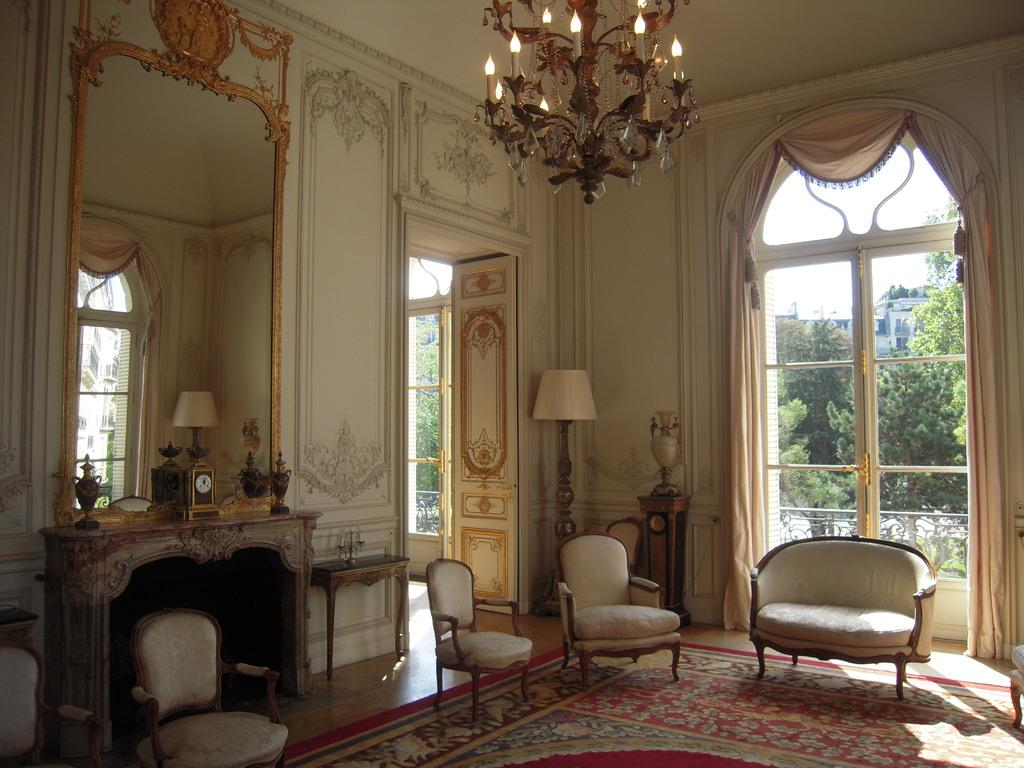What type of furniture is present in the room for seating? There is a sofa and chairs in the room. How can one enter or exit the room? There is a door in the room for entering or exiting. What type of window treatment is present in the room? There are curtains in the room. What type of furniture is present in the room for placing items? There is a table in the room. What type of lighting is present in the room? There is a lamp and a chandelier at the top of the room. What type of vest is hanging on the chair in the room? There is no vest present in the image; only a sofa, chairs, door, curtains, table, lamp, and chandelier are mentioned. What shape is the chair in the room? The facts provided do not mention the shape of the chair, only that there are chairs in the room. 